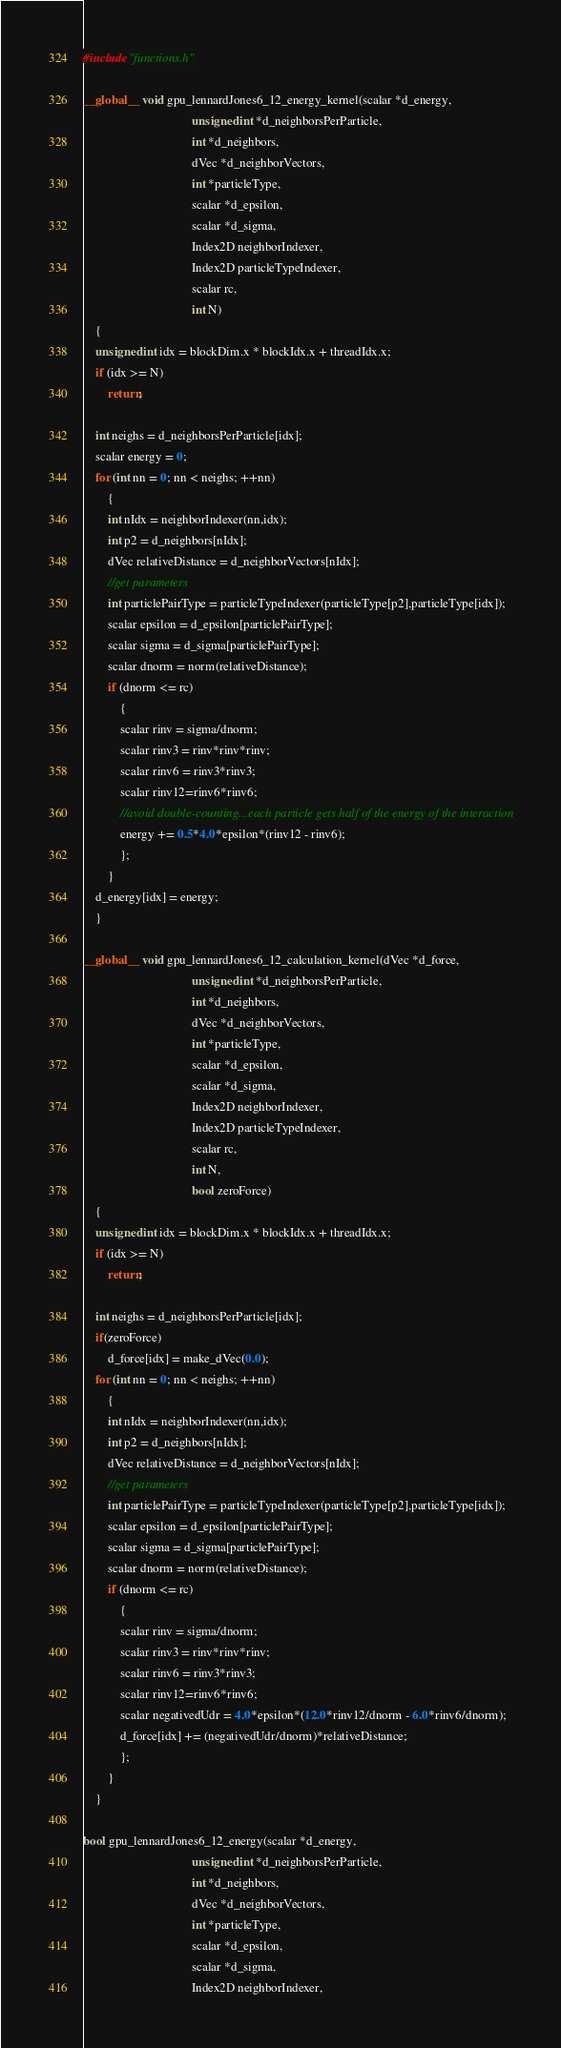<code> <loc_0><loc_0><loc_500><loc_500><_Cuda_>#include "functions.h"

__global__ void gpu_lennardJones6_12_energy_kernel(scalar *d_energy,
                                   unsigned int *d_neighborsPerParticle,
                                   int *d_neighbors,
                                   dVec *d_neighborVectors,
                                   int *particleType,
                                   scalar *d_epsilon,
                                   scalar *d_sigma,
                                   Index2D neighborIndexer,
                                   Index2D particleTypeIndexer,
                                   scalar rc,
                                   int N)
    {
    unsigned int idx = blockDim.x * blockIdx.x + threadIdx.x;
    if (idx >= N)
        return;

    int neighs = d_neighborsPerParticle[idx];
    scalar energy = 0;
    for (int nn = 0; nn < neighs; ++nn)
        {
        int nIdx = neighborIndexer(nn,idx);
        int p2 = d_neighbors[nIdx];
        dVec relativeDistance = d_neighborVectors[nIdx];
        //get parameters
        int particlePairType = particleTypeIndexer(particleType[p2],particleType[idx]);
        scalar epsilon = d_epsilon[particlePairType];
        scalar sigma = d_sigma[particlePairType];
        scalar dnorm = norm(relativeDistance);
        if (dnorm <= rc)
            {
            scalar rinv = sigma/dnorm;
            scalar rinv3 = rinv*rinv*rinv;
            scalar rinv6 = rinv3*rinv3;
            scalar rinv12=rinv6*rinv6;
            //avoid double-counting...each particle gets half of the energy of the interaction
            energy += 0.5*4.0*epsilon*(rinv12 - rinv6);
            };
        }
    d_energy[idx] = energy;
    }

__global__ void gpu_lennardJones6_12_calculation_kernel(dVec *d_force,
                                   unsigned int *d_neighborsPerParticle,
                                   int *d_neighbors,
                                   dVec *d_neighborVectors,
                                   int *particleType,
                                   scalar *d_epsilon,
                                   scalar *d_sigma,
                                   Index2D neighborIndexer,
                                   Index2D particleTypeIndexer,
                                   scalar rc,
                                   int N,
                                   bool zeroForce)
    {
    unsigned int idx = blockDim.x * blockIdx.x + threadIdx.x;
    if (idx >= N)
        return;

    int neighs = d_neighborsPerParticle[idx];
    if(zeroForce)
        d_force[idx] = make_dVec(0.0);
    for (int nn = 0; nn < neighs; ++nn)
        {
        int nIdx = neighborIndexer(nn,idx);
        int p2 = d_neighbors[nIdx];
        dVec relativeDistance = d_neighborVectors[nIdx];
        //get parameters
        int particlePairType = particleTypeIndexer(particleType[p2],particleType[idx]);
        scalar epsilon = d_epsilon[particlePairType];
        scalar sigma = d_sigma[particlePairType];
        scalar dnorm = norm(relativeDistance);
        if (dnorm <= rc)
            {
            scalar rinv = sigma/dnorm;
            scalar rinv3 = rinv*rinv*rinv;
            scalar rinv6 = rinv3*rinv3;
            scalar rinv12=rinv6*rinv6;
            scalar negativedUdr = 4.0*epsilon*(12.0*rinv12/dnorm - 6.0*rinv6/dnorm);
            d_force[idx] += (negativedUdr/dnorm)*relativeDistance;
            };
        }
    }

bool gpu_lennardJones6_12_energy(scalar *d_energy,
                                   unsigned int *d_neighborsPerParticle,
                                   int *d_neighbors,
                                   dVec *d_neighborVectors,
                                   int *particleType,
                                   scalar *d_epsilon,
                                   scalar *d_sigma,
                                   Index2D neighborIndexer,</code> 